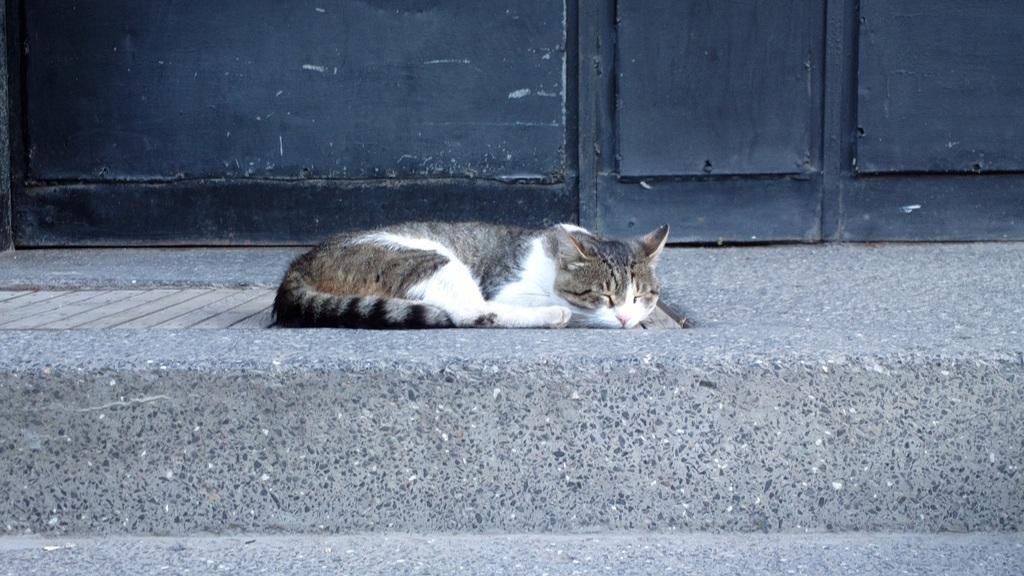Can you describe this image briefly? There is a cat sleeping and lying on a wooden floor. In the back there is a wall. 